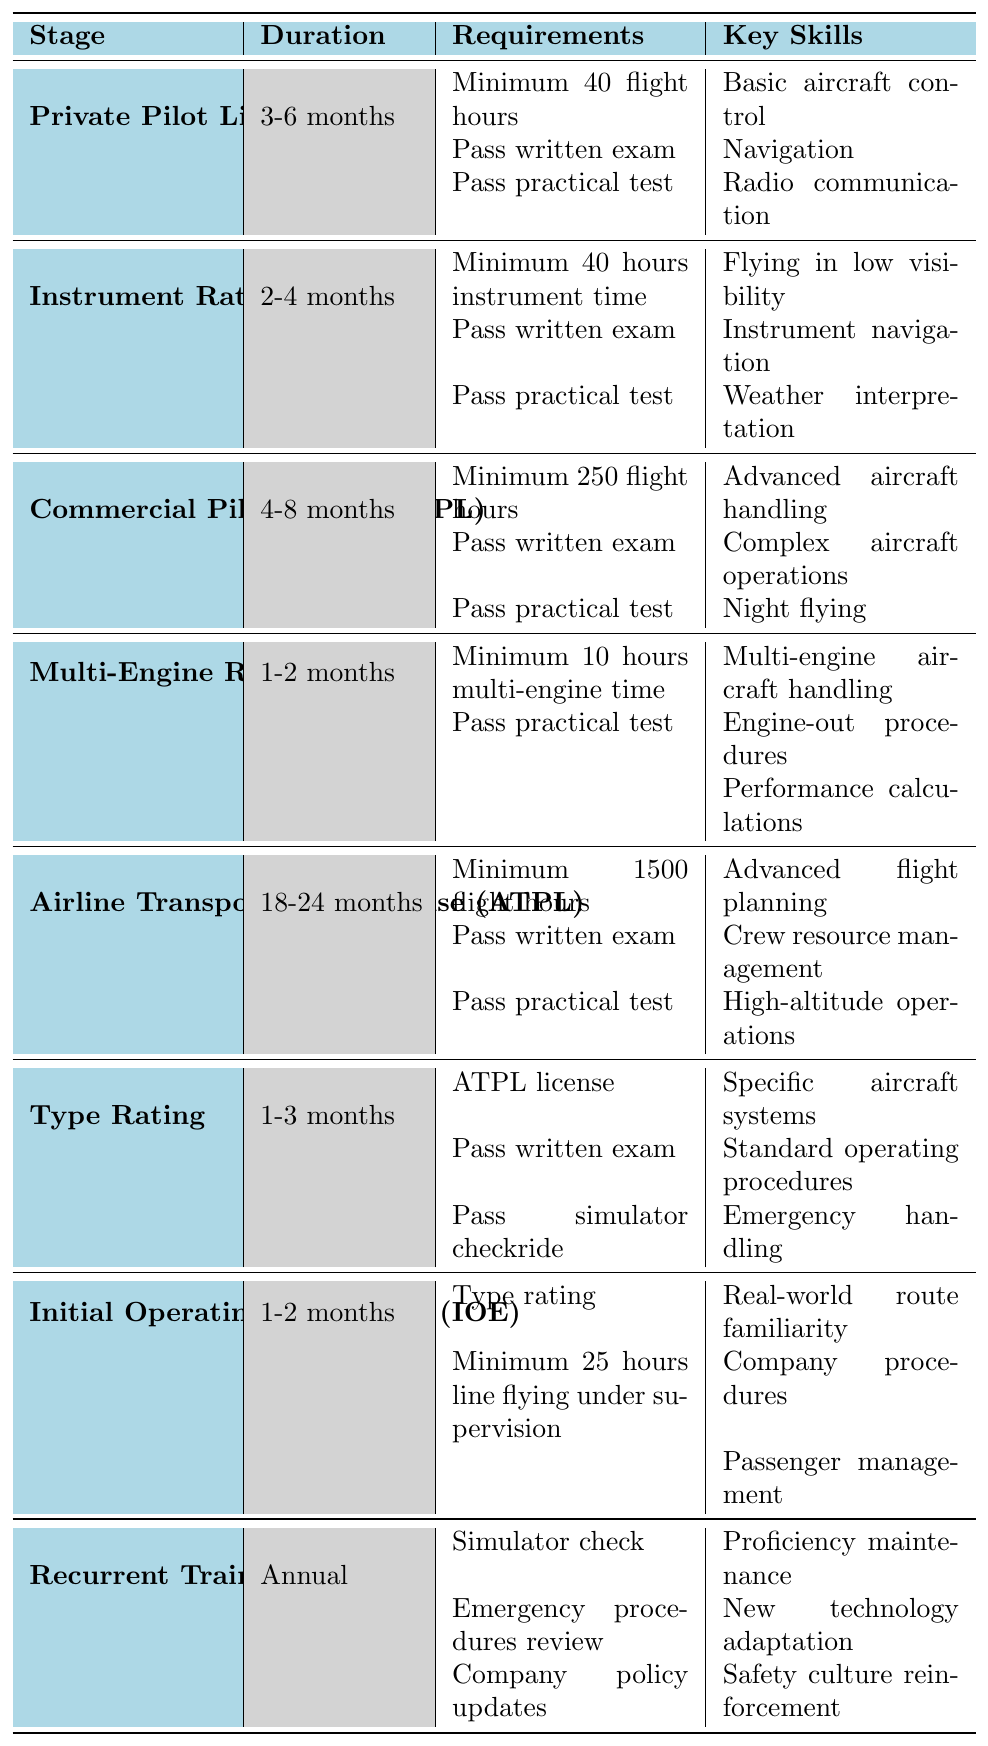What is the duration of the Commercial Pilot License (CPL) stage? The duration for the Commercial Pilot License (CPL) stage is listed in the table as 4-8 months.
Answer: 4-8 months How many flight hours are required for the Airline Transport Pilot License (ATPL)? The requirements for the ATPL stage indicate that a minimum of 1500 flight hours is needed.
Answer: 1500 flight hours Does the Multi-Engine Rating require passing a practical test? According to the table, one of the requirements for the Multi-Engine Rating is to pass a practical test, so the answer is yes.
Answer: Yes What are the key skills developed during the Initial Operating Experience (IOE)? The key skills for IOE listed in the table are real-world route familiarity, company procedures, and passenger management.
Answer: Real-world route familiarity, company procedures, and passenger management Which stage has the longest duration requirement? By examining the durations, the Airline Transport Pilot License (ATPL) has the longest duration at 18-24 months compared to other stages.
Answer: Airline Transport Pilot License (ATPL) If someone completes their Multi-Engine Rating, what is the next stage they could pursue? After completing the Multi-Engine Rating, a pilot typically pursues the Airline Transport Pilot License (ATPL) next as part of the standard progression for commercial pilots.
Answer: Airline Transport Pilot License (ATPL) What is the average duration for all the training stages listed in the table? To find the average duration, we would need to convert all durations into months and average them. The stages and their durations are: PPL (4.5), IR (3), CPL (6), Multi-Engine Rating (1.5), ATPL (21), Type Rating (2), IOE (1.5), and Recurrent Training (12). The total is 50.5 months for 8 stages, so the average is 50.5 / 8 = 6.3125 months.
Answer: Approximately 6.31 months Is it required to possess an ATPL license before pursuing a Type Rating? The table specifies that having an ATPL license is a requirement before obtaining a Type Rating, confirming that this statement is true.
Answer: Yes Compare the key skills of the Instrument Rating (IR) with those of the Commercial Pilot License (CPL). What are the differences? The key skills for IR focus on navigation and weather interpretation for flying in low visibility, whereas the CPL emphasizes advanced handling and complex operations such as night flying. The main difference is that IR is more about instrument flying skills, while CPL includes advanced flight techniques.
Answer: IR focuses on navigation and weather; CPL includes advanced handling and night flying How long does the Recurrent Training stage last? The Recurrent Training stage is noted as an annual requirement, meaning it occurs once each year.
Answer: Annual 